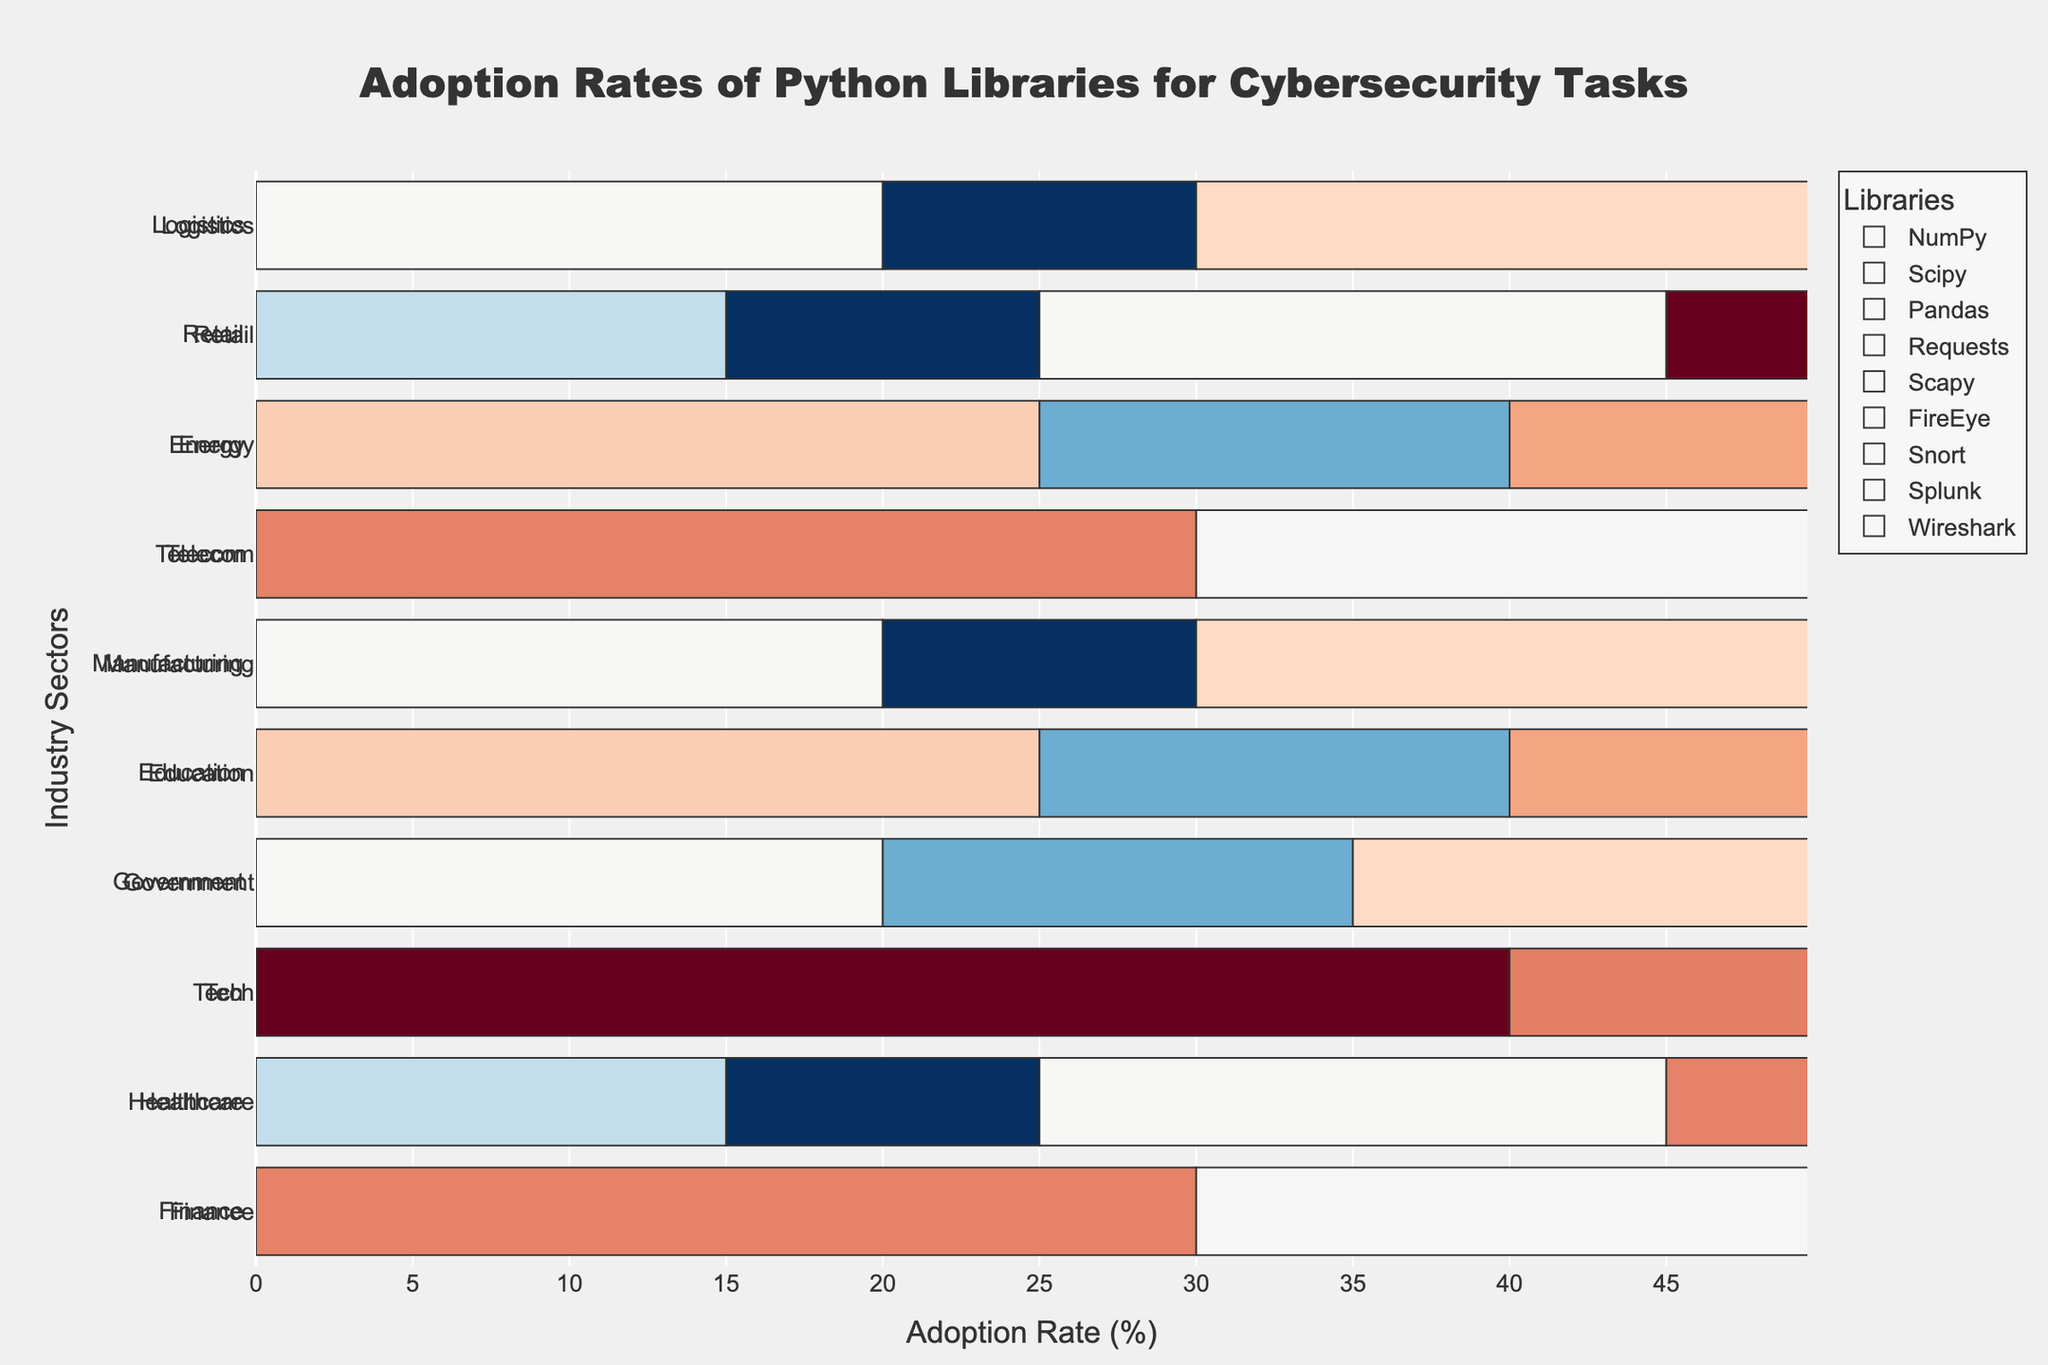Which sector has the highest adoption rate for the library Pandas? By looking at the bar lengths across different sectors, the bar representing the Tech sector is the longest for the library Pandas.
Answer: Tech Among the sectors Finance, Government, and Energy, which one uses the library Scapy the most? Comparing the sectors Finance, Government, and Energy, the bar for Energy for Scapy is the longest, followed by Government and Finance.
Answer: Energy What is the combined adoption rate of FireEye and Scapy in the Healthcare sector? In the Healthcare sector: FireEye has 30, and Scapy has 10. Adding these values: 30 + 10 = 40.
Answer: 40 Which library is more widely adopted in the Telecom sector: Requests or Wireshark? In the Telecom sector, Requests has a bar at the length of 25 while Wireshark has a bar at the length of 20, indicating Requests is more widely adopted.
Answer: Requests What is the average adoption rate of NumPy across the sectors? Adding NumPy adoption rates across all sectors: (30+15+40+20+25+20+30+25+15+20) / 10 = 24.
Answer: 24 Is the adoption rate of Snort in Government higher than the adoption rate of Scapy in Healthcare? In the Government sector, Snort has a bar length of 30. In the Healthcare sector, Scapy has a bar length of 10. Thus, 30 is greater than 10.
Answer: Yes Which sector has the least adoption rate for FireEye, and what is that rate? Observing the bar lengths for FireEye across all sectors, Education has the shortest bar at the rate of 15.
Answer: Education What is the total adoption rate of Requests across all sectors? Summing up the adoption rates of Requests across all sectors: 10+25+30+25+20+20+25+20+30+15 = 220.
Answer: 220 Which sector has a higher adoption rate of Splunk: Tech or Logistics? In the Tech sector, Splunk has a bar length of 35. In Logistics, Splunk has a bar length of 10. Hence, Tech has a higher adoption rate for Splunk.
Answer: Tech 